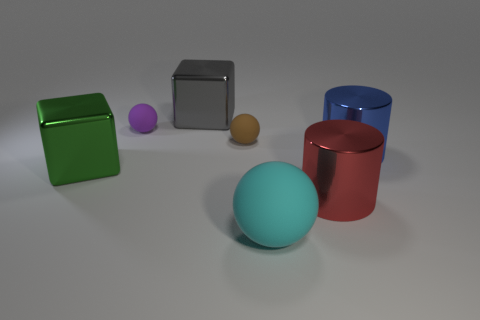Add 2 big cylinders. How many objects exist? 9 Subtract all blocks. How many objects are left? 5 Add 3 large green shiny things. How many large green shiny things are left? 4 Add 1 metallic objects. How many metallic objects exist? 5 Subtract 0 red spheres. How many objects are left? 7 Subtract all metallic objects. Subtract all small brown rubber objects. How many objects are left? 2 